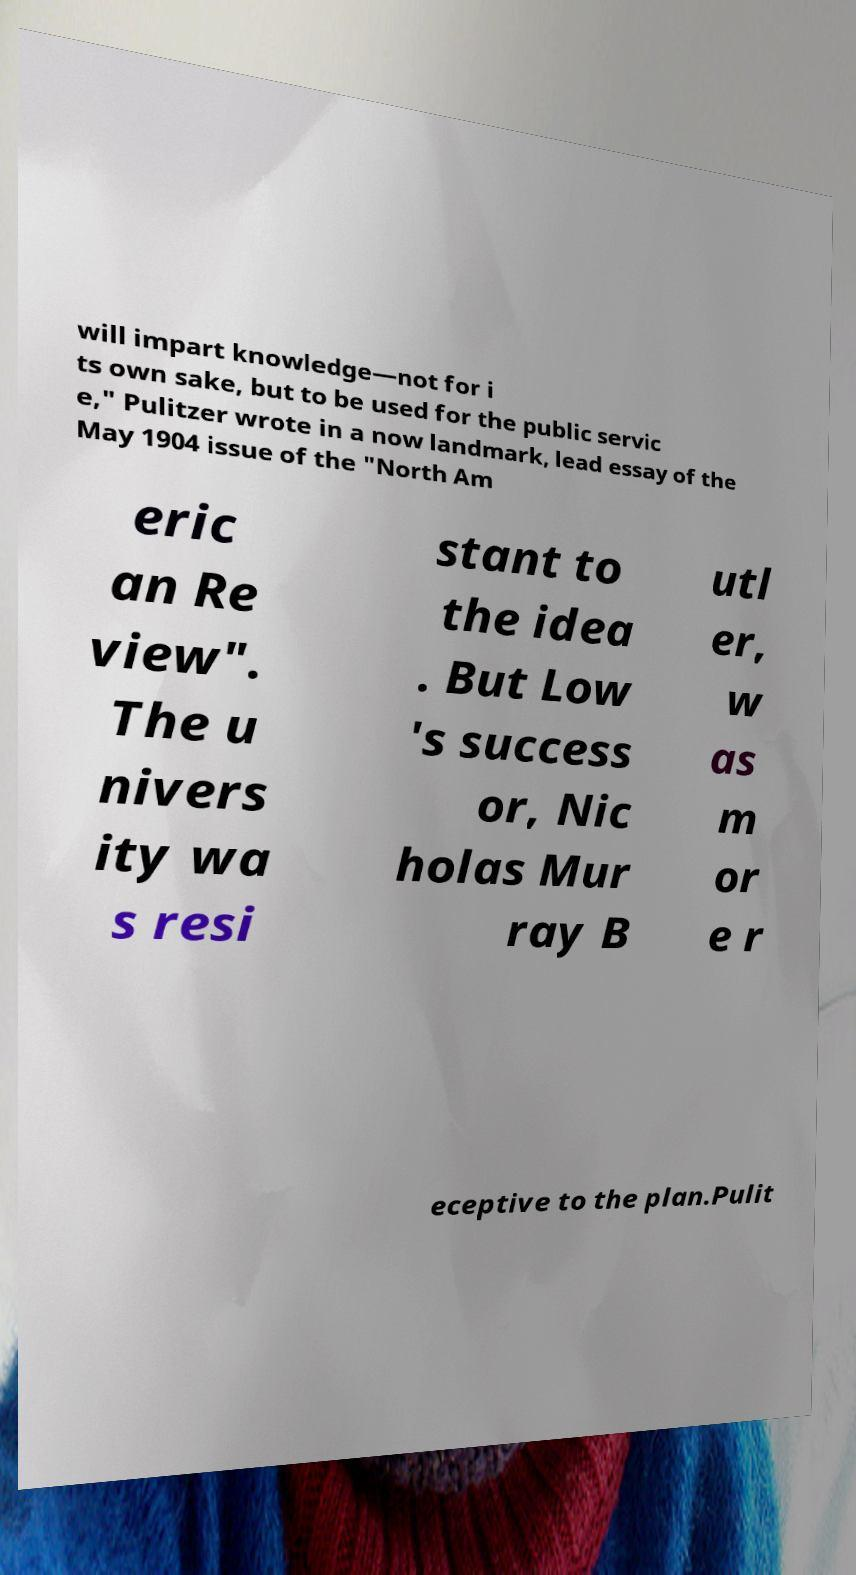Please identify and transcribe the text found in this image. will impart knowledge—not for i ts own sake, but to be used for the public servic e," Pulitzer wrote in a now landmark, lead essay of the May 1904 issue of the "North Am eric an Re view". The u nivers ity wa s resi stant to the idea . But Low 's success or, Nic holas Mur ray B utl er, w as m or e r eceptive to the plan.Pulit 